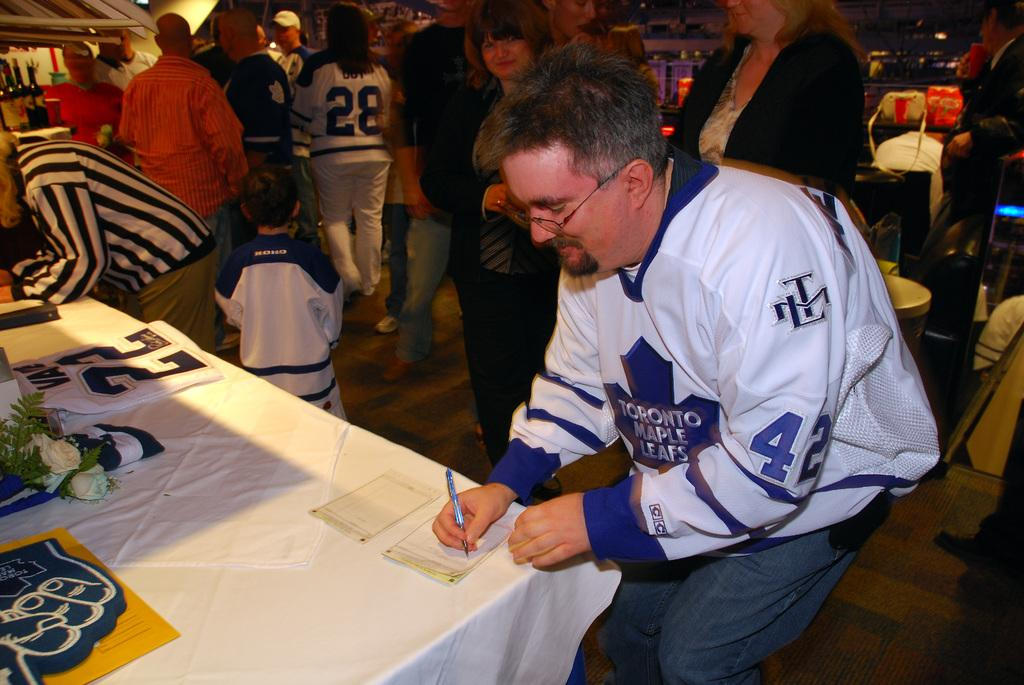<image>
Create a compact narrative representing the image presented. A man in a Toronto Maple Leafs jersey writing at a table. 